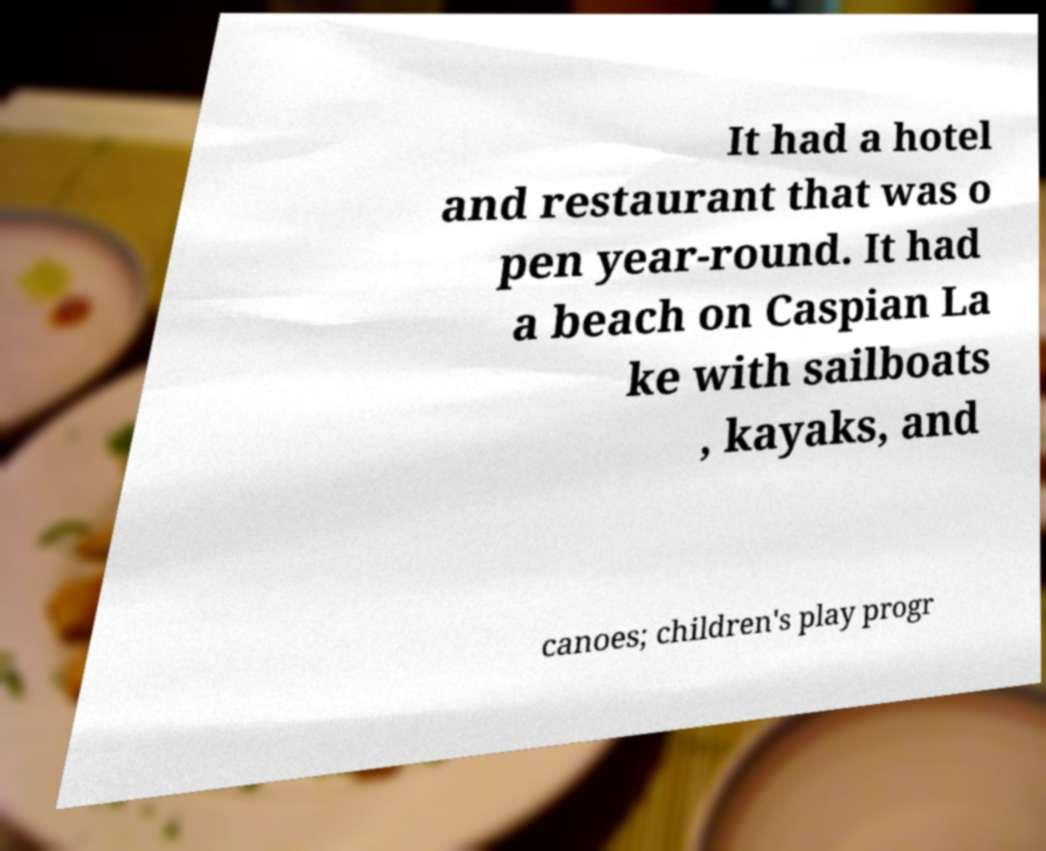Could you extract and type out the text from this image? It had a hotel and restaurant that was o pen year-round. It had a beach on Caspian La ke with sailboats , kayaks, and canoes; children's play progr 